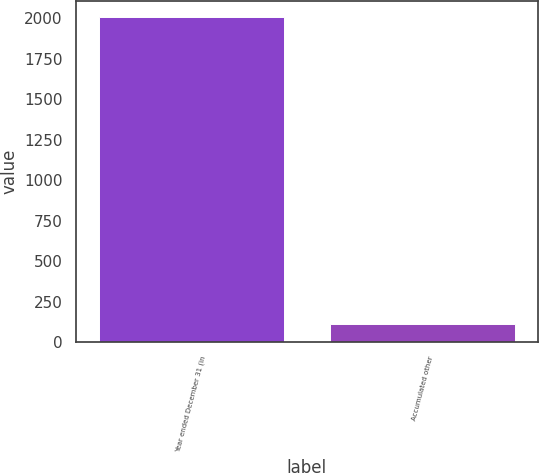Convert chart to OTSL. <chart><loc_0><loc_0><loc_500><loc_500><bar_chart><fcel>Year ended December 31 (in<fcel>Accumulated other<nl><fcel>2008<fcel>113<nl></chart> 